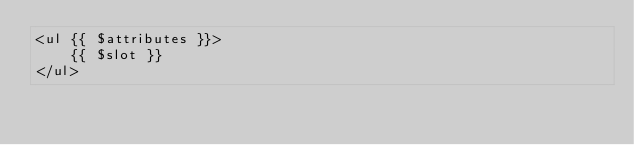Convert code to text. <code><loc_0><loc_0><loc_500><loc_500><_PHP_><ul {{ $attributes }}>
    {{ $slot }}
</ul>
</code> 